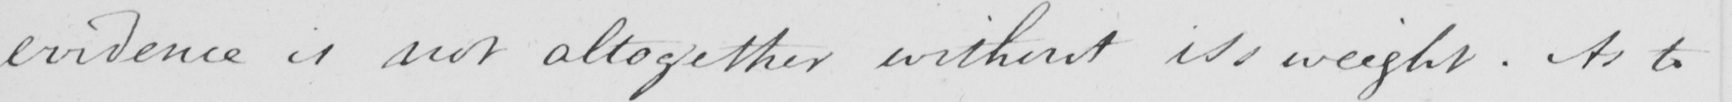Please transcribe the handwritten text in this image. evidence is not altogether without its weight . As to 